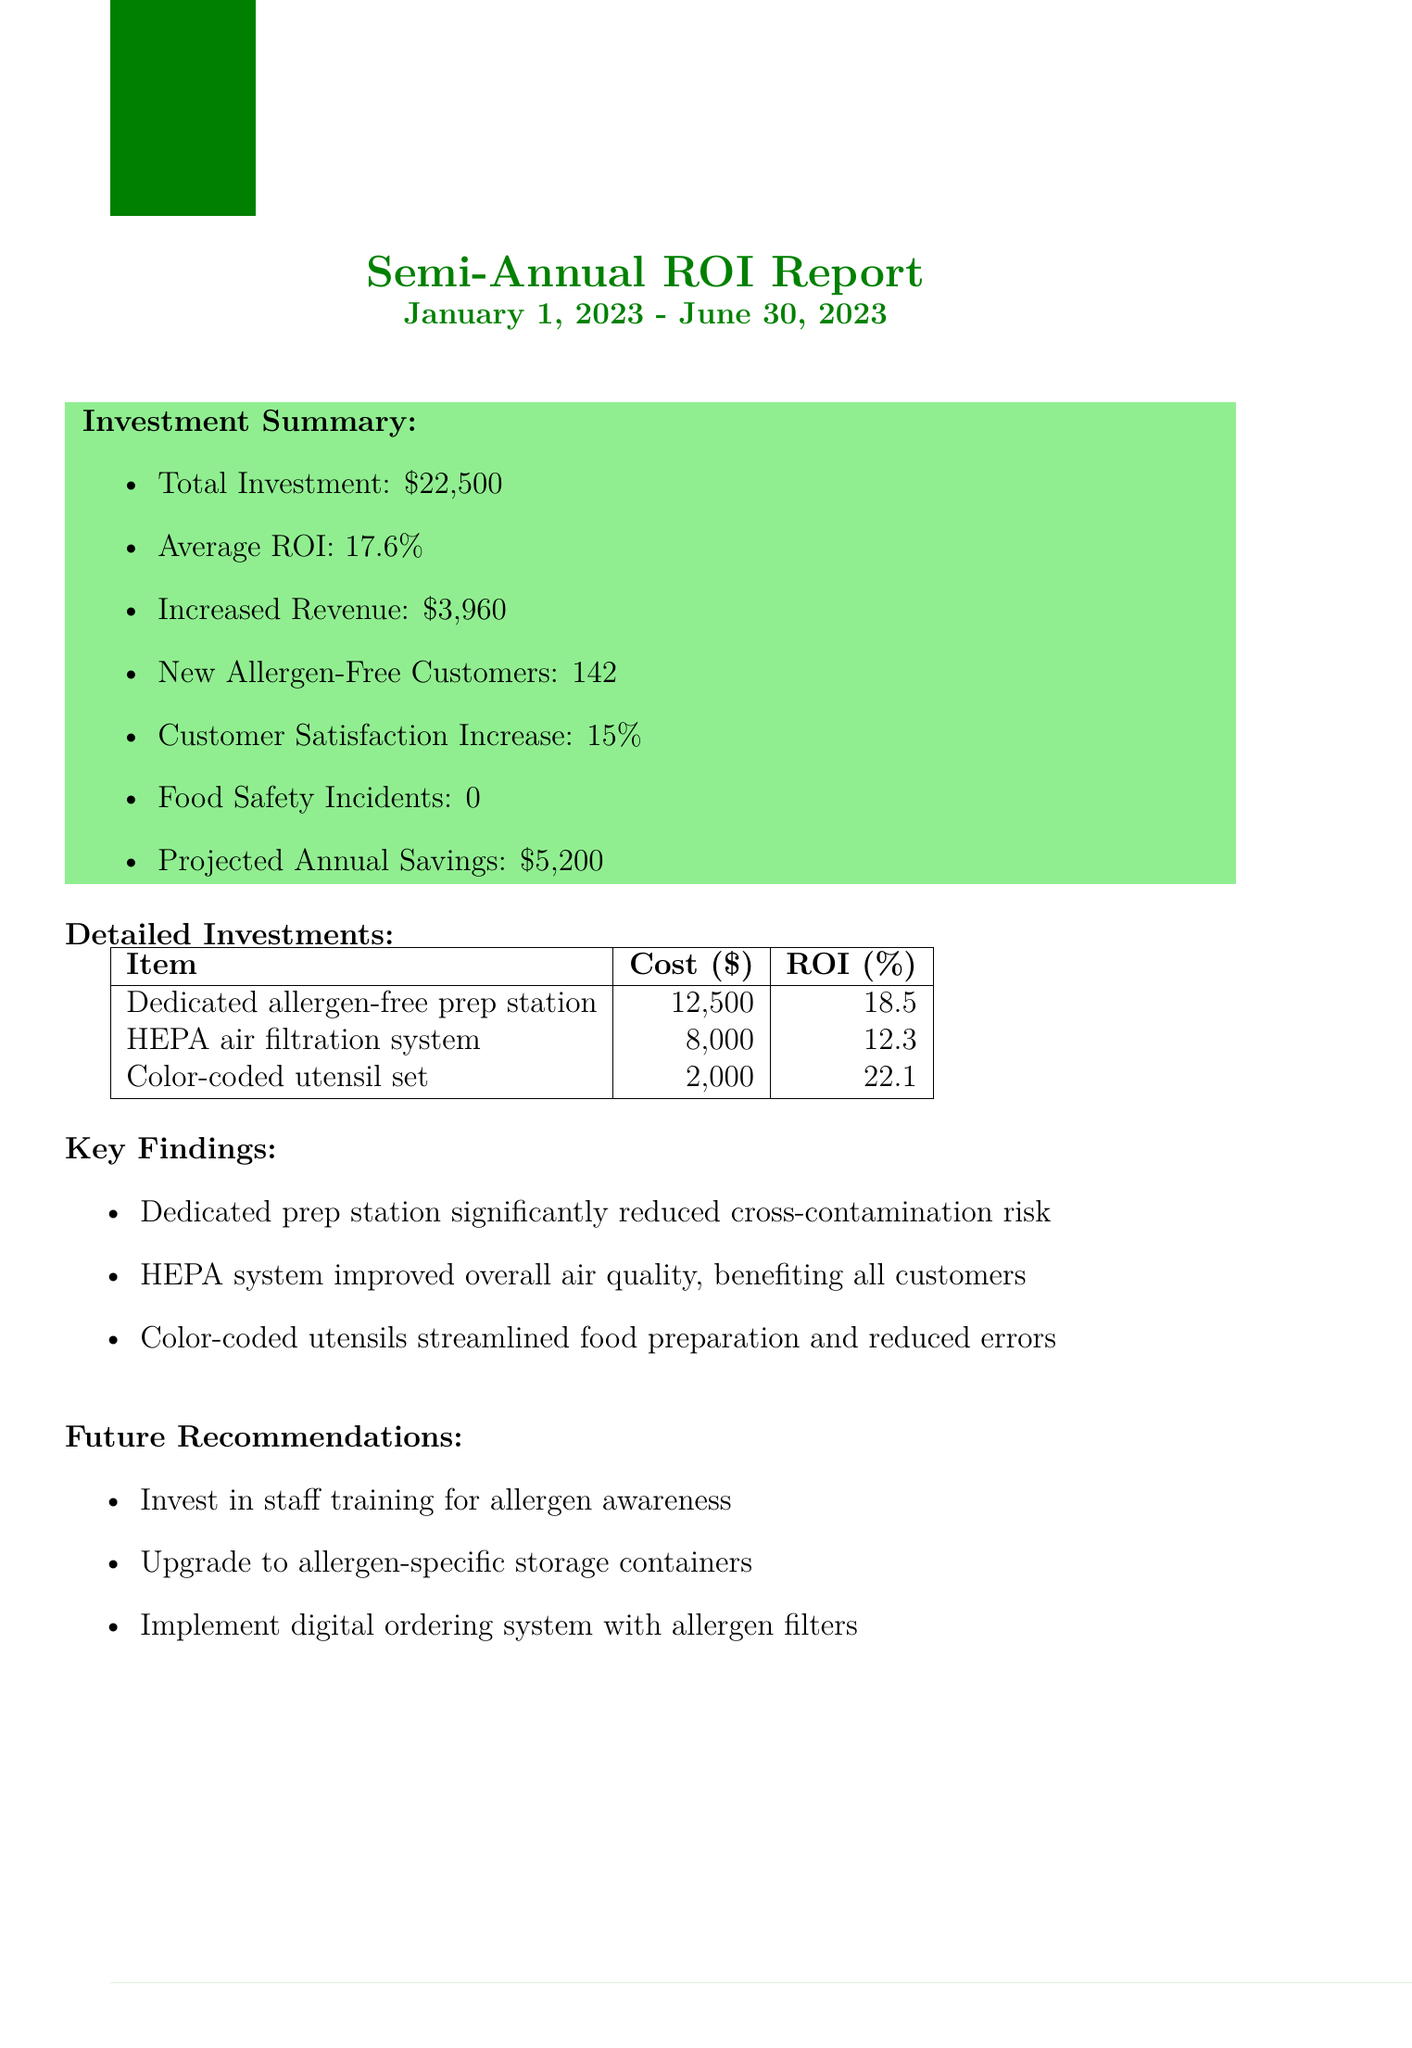What is the restaurant name? The restaurant name is mentioned at the beginning of the document as "SafePlate Bistro".
Answer: SafePlate Bistro What is the reporting period for this report? The document states the reporting period as "January 1, 2023 - June 30, 2023".
Answer: January 1, 2023 - June 30, 2023 What was the total investment made? The total investment is explicitly listed in the investment summary section of the document as "$22,500".
Answer: $22,500 What is the average ROI? The average ROI is provided in the investment summary as "17.6%".
Answer: 17.6% How many new allergen-free customers were gained? The increase in new allergen-free customers is reported as "142".
Answer: 142 Which item had the highest ROI? The detailed investments section indicates that the "Color-coded utensil set" had the highest ROI at "22.1%".
Answer: Color-coded utensil set What is one of the key findings? Key findings are listed in the document; one of them states the "Dedicated prep station significantly reduced cross-contamination risk".
Answer: Dedicated prep station significantly reduced cross-contamination risk What is a future recommendation from the report? The report mentions that one future recommendation is to "Invest in staff training for allergen awareness".
Answer: Invest in staff training for allergen awareness What was the customer satisfaction increase percentage? This percentage is noted in the investment summary section as "15%".
Answer: 15% 